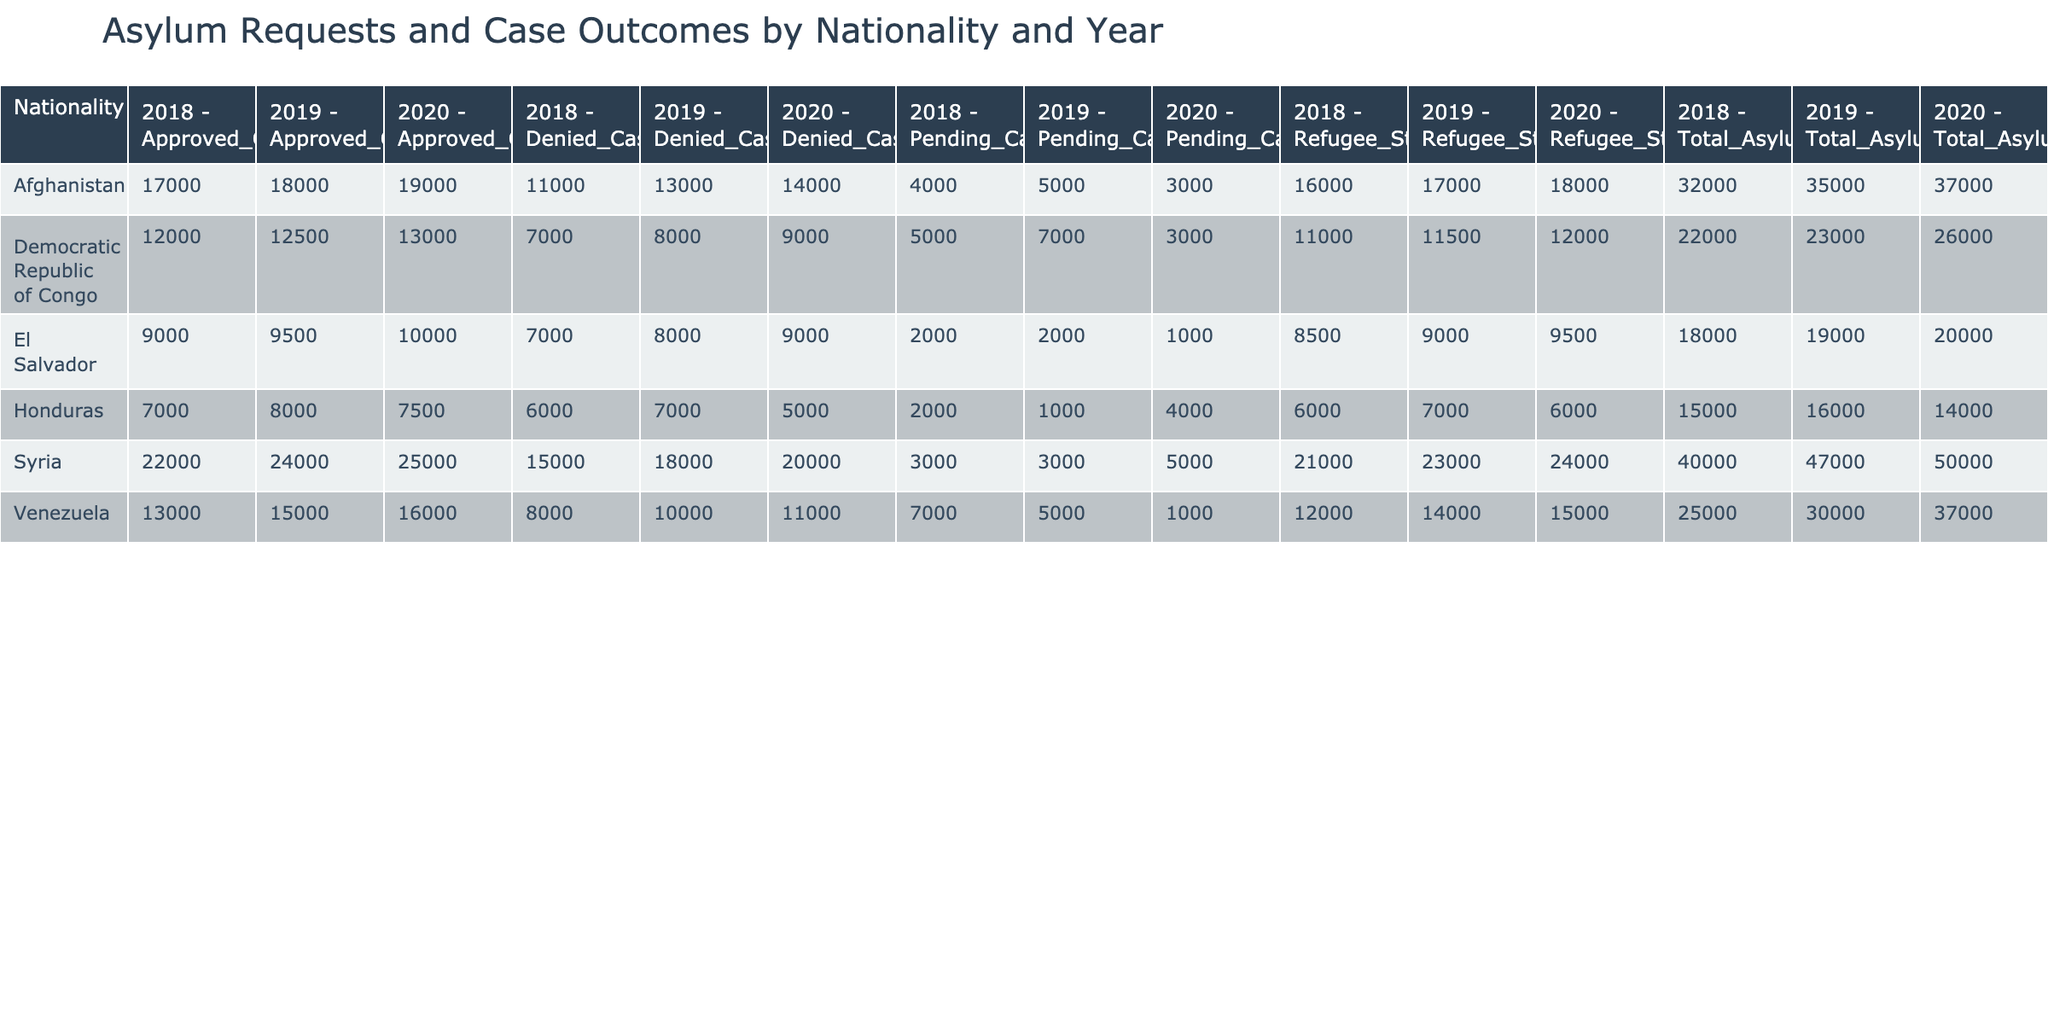What was the total number of asylum requests from Syria in 2019? The table shows that the total number of asylum requests from Syria in 2019 is listed as 47,000 under the "Total_Asylum_Requests" column.
Answer: 47,000 Which nationality received the highest number of approved cases in 2020? By looking at the "Approved_Cases" column for 2020, we can see that Syria had 25,000 approved cases, which is more than any other nationality listed for that year.
Answer: Syria How many denied cases were there for Afghanistan in 2019? The table indicates that Afghanistan had 13,000 denied cases in 2019 under the "Denied_Cases" column.
Answer: 13,000 What is the total number of pending cases for Venezuela across all years? To find the total, sum the pending cases for Venezuela in each year: 7,000 (2018) + 5,000 (2019) + 1,000 (2020) = 13,000.
Answer: 13,000 Is the number of total asylum requests from Honduras increasing or decreasing from 2018 to 2020? For Honduras, the total asylum requests were 15,000 in 2018, 16,000 in 2019, and 14,000 in 2020. This indicates a decrease from 2019 to 2020 after an increase from 2018 to 2019.
Answer: Decreasing What was the average number of approved cases per year for the Democratic Republic of Congo? To calculate the average, sum the approved cases for the Democratic Republic of Congo: 12,000 (2018) + 12,500 (2019) + 13,000 (2020) = 37,500. Then divide by 3 (the number of years): 37,500 / 3 = 12,500.
Answer: 12,500 How many more total asylum requests were submitted from Syria than from El Salvador in 2020? In 2020, Syria had 50,000 total asylum requests while El Salvador had 20,000. The difference is 50,000 - 20,000 = 30,000 more requests from Syria.
Answer: 30,000 Did Afghanistan receive a higher number of approved cases than Honduras in 2018? In 2018, Afghanistan had 17,000 approved cases while Honduras had 7,000. Since 17,000 is greater than 7,000, the answer is yes.
Answer: Yes What is the trend of refugee status awarded for El Salvador from 2018 to 2020? The refugee status awarded in El Salvador increased from 8,500 in 2018 to 9,500 in 2020, indicating an upward trend.
Answer: Upward trend Which nationality had the highest number of denied cases in 2020? In 2020, Syria had the highest number of denied cases with 20,000, making it the clear leader in denied cases that year.
Answer: Syria 